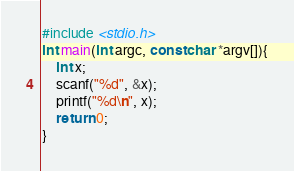<code> <loc_0><loc_0><loc_500><loc_500><_C_>#include <stdio.h>
int main(int argc, const char *argv[]){
    int x;
    scanf("%d", &x);
    printf("%d\n", x);
    return 0;
}</code> 